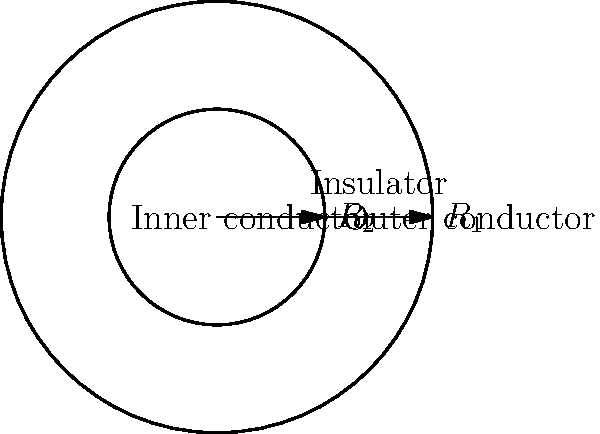As part of your mentoring session with engineering students, you're discussing the design of a coaxial cable. The cable has an outer conductor with radius $R_1 = 3$ mm and an inner conductor with radius $R_2 = 1.5$ mm. Calculate the cross-sectional area of the insulator between the two conductors. Express your answer in square millimeters (mm²) and round to two decimal places. To solve this problem, we'll follow these steps:

1) The cross-sectional area of the insulator is the difference between the area of the outer circle (defined by $R_1$) and the area of the inner circle (defined by $R_2$).

2) The area of a circle is given by the formula $A = \pi r^2$, where $r$ is the radius.

3) For the outer circle:
   $A_1 = \pi R_1^2 = \pi (3 \text{ mm})^2 = 9\pi \text{ mm}^2$

4) For the inner circle:
   $A_2 = \pi R_2^2 = \pi (1.5 \text{ mm})^2 = 2.25\pi \text{ mm}^2$

5) The area of the insulator is the difference:
   $A_{insulator} = A_1 - A_2 = 9\pi \text{ mm}^2 - 2.25\pi \text{ mm}^2 = 6.75\pi \text{ mm}^2$

6) Calculate the final value:
   $A_{insulator} = 6.75\pi \text{ mm}^2 \approx 21.21 \text{ mm}^2$

7) Rounding to two decimal places: 21.21 mm²
Answer: 21.21 mm² 